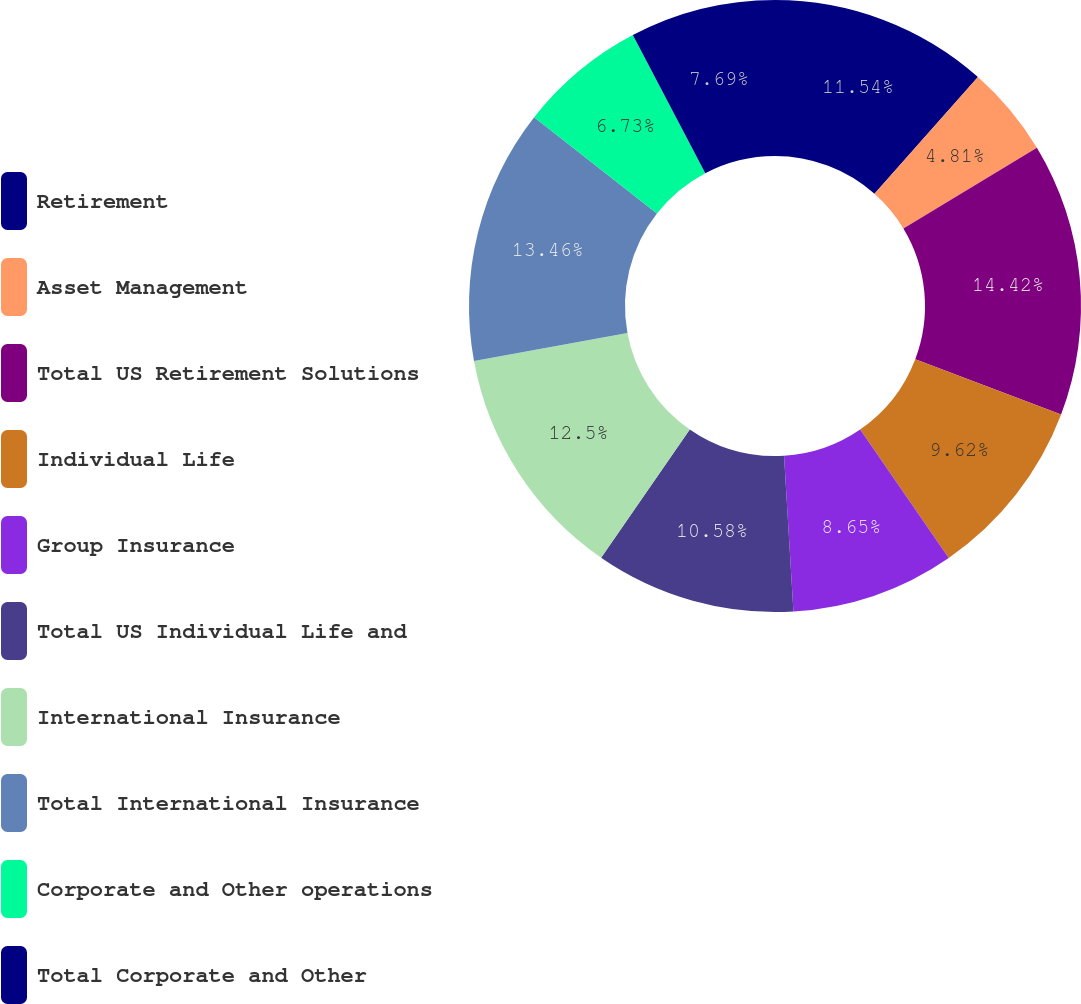Convert chart. <chart><loc_0><loc_0><loc_500><loc_500><pie_chart><fcel>Retirement<fcel>Asset Management<fcel>Total US Retirement Solutions<fcel>Individual Life<fcel>Group Insurance<fcel>Total US Individual Life and<fcel>International Insurance<fcel>Total International Insurance<fcel>Corporate and Other operations<fcel>Total Corporate and Other<nl><fcel>11.54%<fcel>4.81%<fcel>14.42%<fcel>9.62%<fcel>8.65%<fcel>10.58%<fcel>12.5%<fcel>13.46%<fcel>6.73%<fcel>7.69%<nl></chart> 